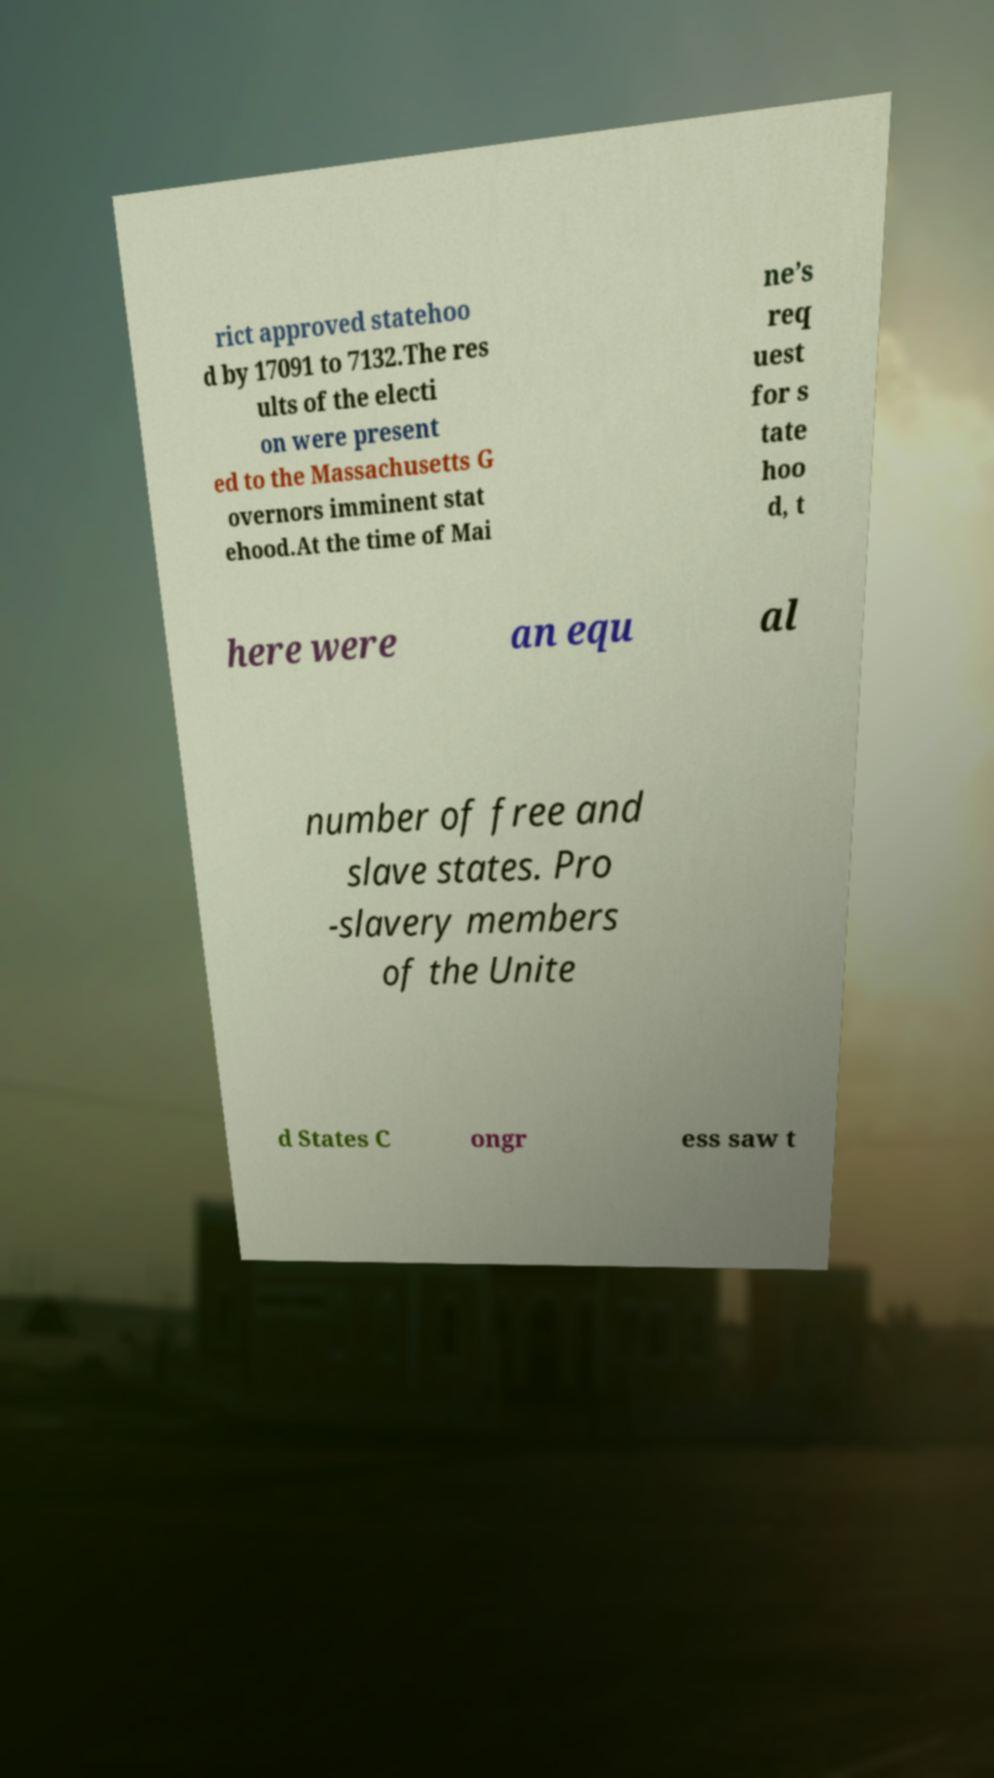There's text embedded in this image that I need extracted. Can you transcribe it verbatim? rict approved statehoo d by 17091 to 7132.The res ults of the electi on were present ed to the Massachusetts G overnors imminent stat ehood.At the time of Mai ne’s req uest for s tate hoo d, t here were an equ al number of free and slave states. Pro -slavery members of the Unite d States C ongr ess saw t 